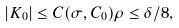Convert formula to latex. <formula><loc_0><loc_0><loc_500><loc_500>| K _ { 0 } | \leq C ( \sigma , C _ { 0 } ) \rho \leq \delta / 8 ,</formula> 